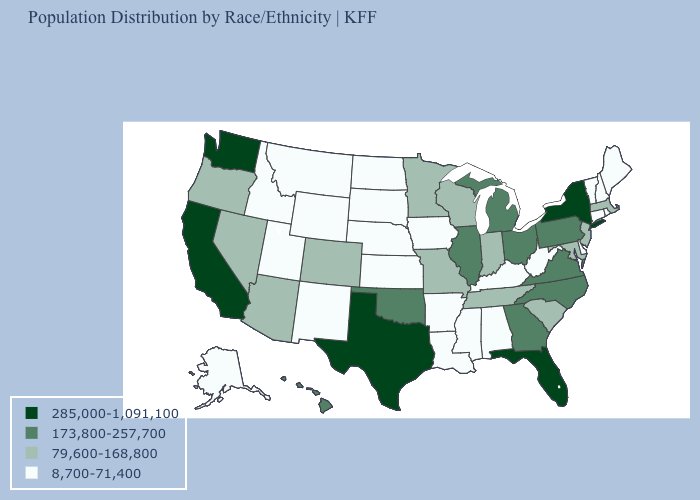Does the map have missing data?
Write a very short answer. No. Among the states that border Utah , does Arizona have the highest value?
Concise answer only. Yes. Does Georgia have a lower value than California?
Be succinct. Yes. Does California have a higher value than North Dakota?
Short answer required. Yes. What is the lowest value in states that border Maine?
Keep it brief. 8,700-71,400. What is the value of Michigan?
Concise answer only. 173,800-257,700. Which states have the highest value in the USA?
Write a very short answer. California, Florida, New York, Texas, Washington. Does Nevada have the highest value in the West?
Keep it brief. No. Is the legend a continuous bar?
Short answer required. No. Does Texas have the highest value in the South?
Give a very brief answer. Yes. Name the states that have a value in the range 79,600-168,800?
Give a very brief answer. Arizona, Colorado, Indiana, Maryland, Massachusetts, Minnesota, Missouri, Nevada, New Jersey, Oregon, South Carolina, Tennessee, Wisconsin. Name the states that have a value in the range 8,700-71,400?
Concise answer only. Alabama, Alaska, Arkansas, Connecticut, Delaware, Idaho, Iowa, Kansas, Kentucky, Louisiana, Maine, Mississippi, Montana, Nebraska, New Hampshire, New Mexico, North Dakota, Rhode Island, South Dakota, Utah, Vermont, West Virginia, Wyoming. Name the states that have a value in the range 285,000-1,091,100?
Give a very brief answer. California, Florida, New York, Texas, Washington. Among the states that border Georgia , which have the highest value?
Write a very short answer. Florida. Name the states that have a value in the range 79,600-168,800?
Give a very brief answer. Arizona, Colorado, Indiana, Maryland, Massachusetts, Minnesota, Missouri, Nevada, New Jersey, Oregon, South Carolina, Tennessee, Wisconsin. 